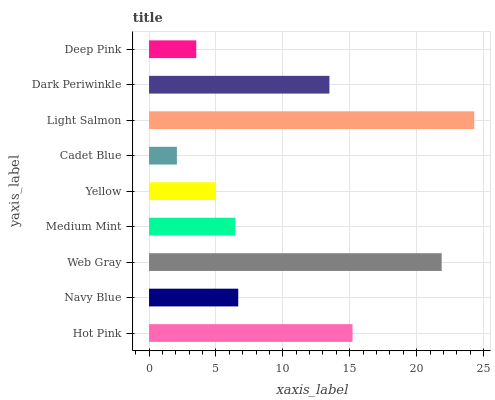Is Cadet Blue the minimum?
Answer yes or no. Yes. Is Light Salmon the maximum?
Answer yes or no. Yes. Is Navy Blue the minimum?
Answer yes or no. No. Is Navy Blue the maximum?
Answer yes or no. No. Is Hot Pink greater than Navy Blue?
Answer yes or no. Yes. Is Navy Blue less than Hot Pink?
Answer yes or no. Yes. Is Navy Blue greater than Hot Pink?
Answer yes or no. No. Is Hot Pink less than Navy Blue?
Answer yes or no. No. Is Navy Blue the high median?
Answer yes or no. Yes. Is Navy Blue the low median?
Answer yes or no. Yes. Is Hot Pink the high median?
Answer yes or no. No. Is Medium Mint the low median?
Answer yes or no. No. 